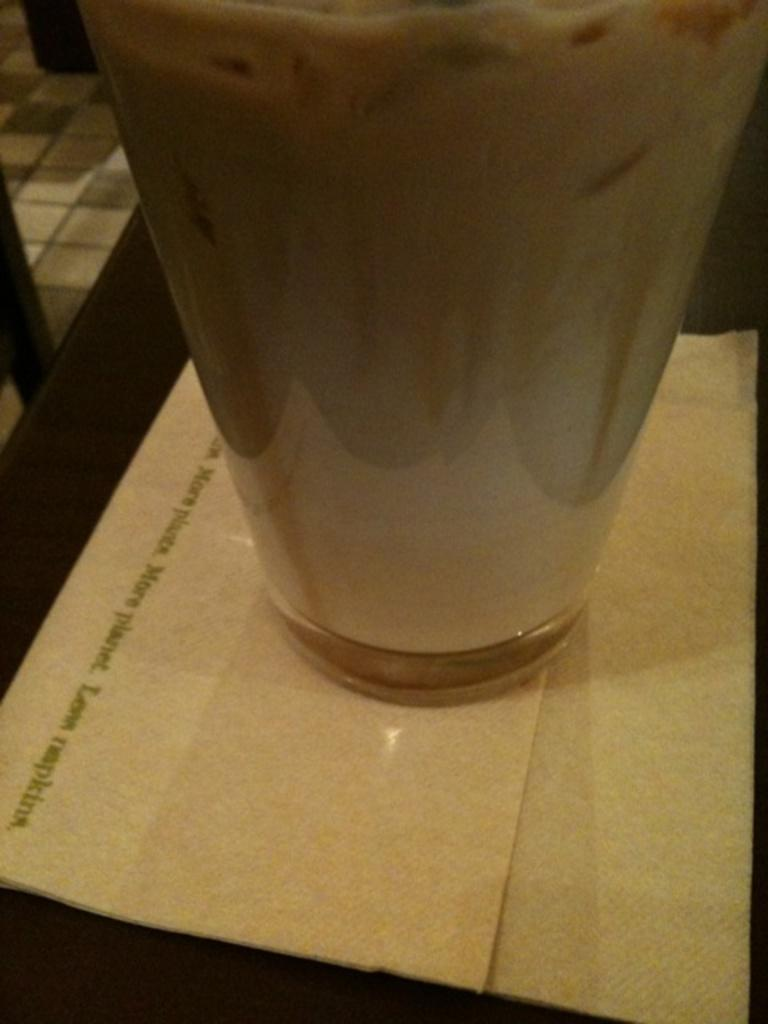What type of furniture is present in the image? There is a table in the image. What is hanging above the table? There is a tissue paper and a glass hanging above the table. What type of flooring is visible in the image? The top left side of the image shows a tile floor. What type of advice can be seen written on the tissue paper? There is no advice visible on the tissue paper in the image. 